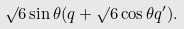Convert formula to latex. <formula><loc_0><loc_0><loc_500><loc_500>\surd 6 \sin \theta ( q + \surd 6 \cos \theta q ^ { \prime } ) .</formula> 